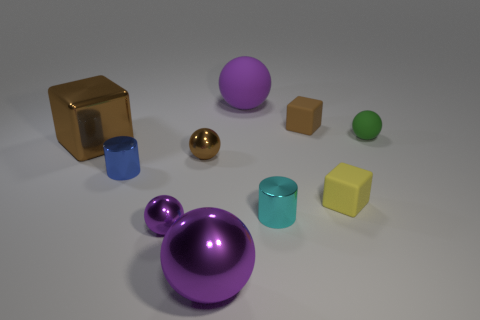Subtract all gray cubes. How many purple balls are left? 3 Subtract all green spheres. How many spheres are left? 4 Subtract all large shiny balls. How many balls are left? 4 Subtract 2 spheres. How many spheres are left? 3 Subtract all cyan balls. Subtract all yellow cylinders. How many balls are left? 5 Subtract all cylinders. How many objects are left? 8 Add 5 large purple shiny objects. How many large purple shiny objects are left? 6 Add 4 large purple matte spheres. How many large purple matte spheres exist? 5 Subtract 1 yellow blocks. How many objects are left? 9 Subtract all yellow things. Subtract all green balls. How many objects are left? 8 